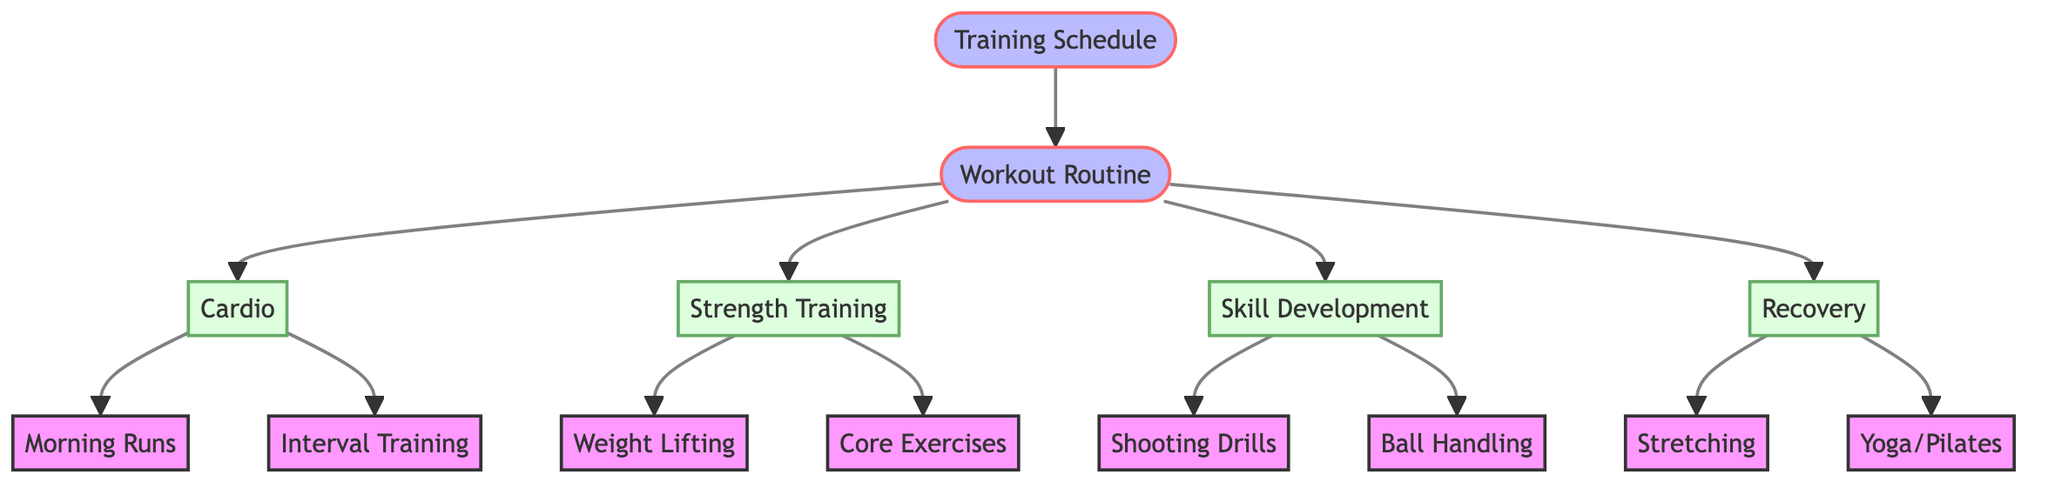What are the two main branches of the workout routine? The diagram connects "Workout Routine" to two main categories: "Cardio" and "Strength Training." These are the first two nodes that are directly linked to the "Workout Routine" node.
Answer: Cardio, Strength Training How many total nodes are present in the diagram? Counting all the entries listed in the nodes section, we find 14 unique nodes representing different aspects of training schedules and workout routines for basketball players.
Answer: 14 Which recovery activities are listed in the diagram? The "Recovery" node connects to two activities: "Stretching" and "Yoga/Pilates." These activities are explicitly branched from the "Recovery" node indicating the focus on recovery in the training schedule.
Answer: Stretching, Yoga/Pilates What is the relationship between "Skill Development" and "Shooting Drills"? The diagram shows a direct link from the "Skill Development" node to the "Shooting Drills" node, indicating that shooting drills are a component of skill development in basketball.
Answer: Direct connection Which type of training includes "Weight Lifting"? The diagram indicates that "Weight Lifting" is connected to the "Strength Training" node, meaning that weight lifting is a part of the strength training regimen for aspiring basketball players.
Answer: Strength Training How many types of cardio workouts are listed? The "Cardio" node branches out to two specific workouts: "Morning Runs" and "Interval Training," totaling two types of cardio workouts in the diagram.
Answer: 2 What type of exercises fall under the strength training category? The "Strength Training" node connects to two specific types of exercises: "Weight Lifting" and "Core Exercises," detailing the focus areas for strength training in basketball preparation.
Answer: Weight Lifting, Core Exercises What is the central focus of the diagram? The primary focus of the diagram is on the "Training Schedule," as it serves as the main entry point, linking to all workout routines and recovery methods essential for basketball training.
Answer: Training Schedule Which node directly connects to both "Cardio" and "Strength Training"? "Workout Routine" serves as the connector between "Cardio" and "Strength Training," acting as the central node from which these two categories branch out.
Answer: Workout Routine 